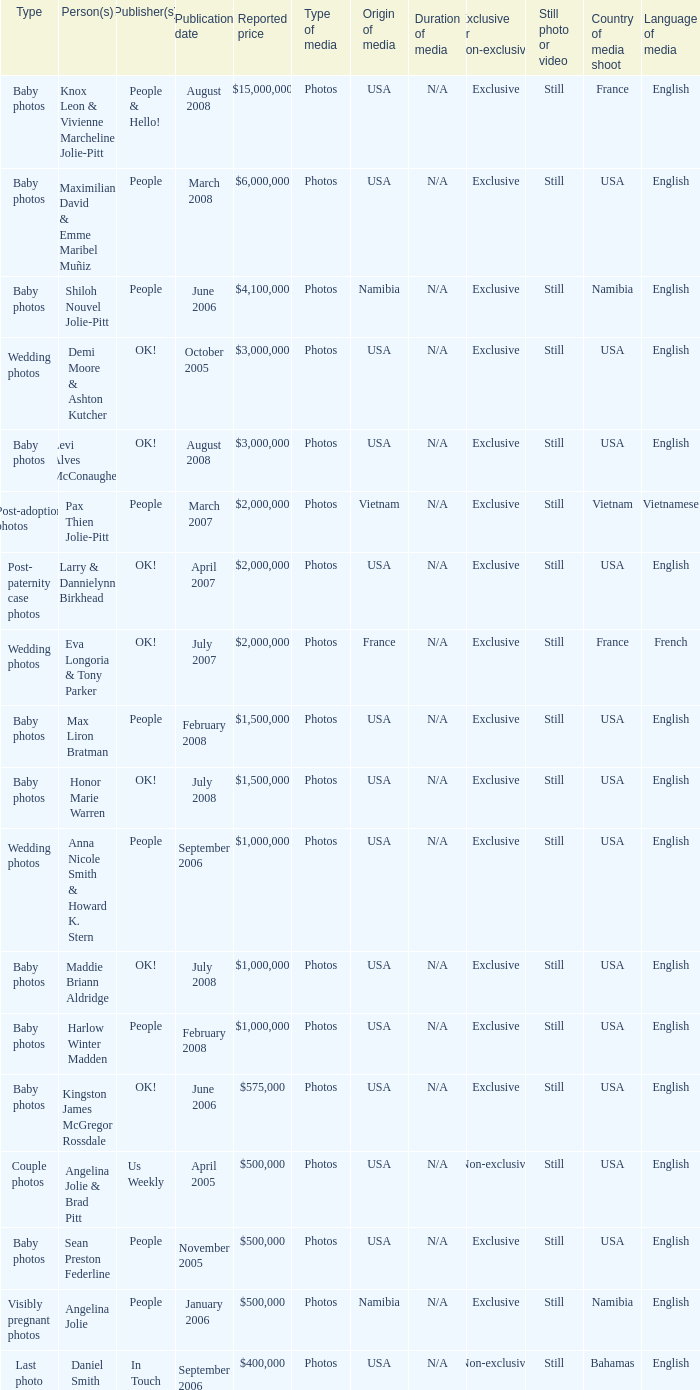What type of photos of Angelina Jolie cost $500,000? Visibly pregnant photos. 